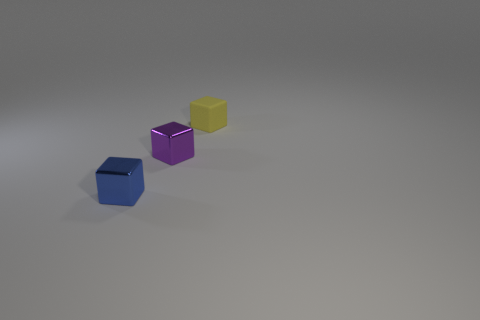Subtract all cyan blocks. Subtract all purple balls. How many blocks are left? 3 Add 1 gray rubber cylinders. How many objects exist? 4 Add 2 metal objects. How many metal objects are left? 4 Add 1 small blocks. How many small blocks exist? 4 Subtract 0 yellow cylinders. How many objects are left? 3 Subtract all small blue objects. Subtract all yellow metal cubes. How many objects are left? 2 